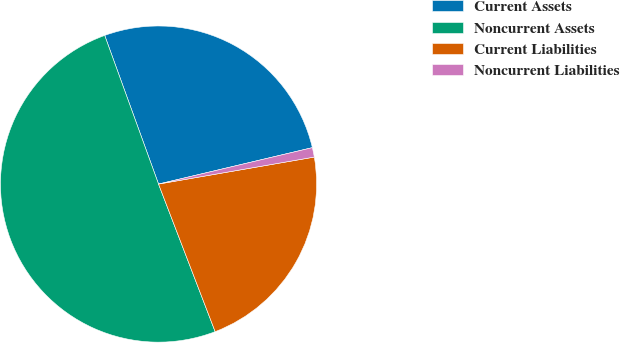<chart> <loc_0><loc_0><loc_500><loc_500><pie_chart><fcel>Current Assets<fcel>Noncurrent Assets<fcel>Current Liabilities<fcel>Noncurrent Liabilities<nl><fcel>26.83%<fcel>50.3%<fcel>21.9%<fcel>0.97%<nl></chart> 